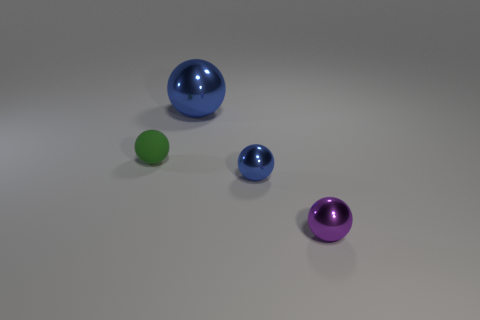Subtract all cyan spheres. Subtract all yellow cylinders. How many spheres are left? 4 Add 3 large purple shiny cubes. How many objects exist? 7 Add 2 tiny gray cubes. How many tiny gray cubes exist? 2 Subtract 0 green cylinders. How many objects are left? 4 Subtract all small purple rubber cylinders. Subtract all small blue metal objects. How many objects are left? 3 Add 3 tiny blue objects. How many tiny blue objects are left? 4 